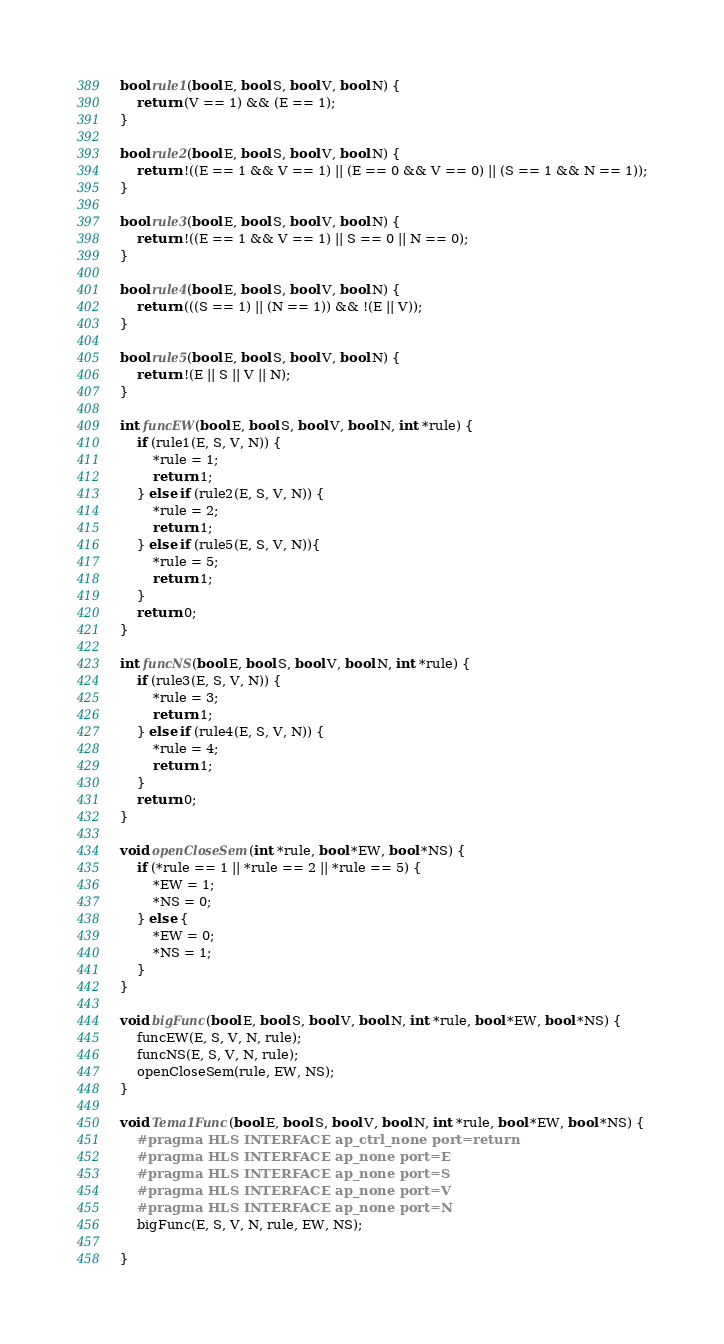Convert code to text. <code><loc_0><loc_0><loc_500><loc_500><_C++_>bool rule1(bool E, bool S, bool V, bool N) {
	return (V == 1) && (E == 1);
}

bool rule2(bool E, bool S, bool V, bool N) {
	return !((E == 1 && V == 1) || (E == 0 && V == 0) || (S == 1 && N == 1));
}

bool rule3(bool E, bool S, bool V, bool N) {
	return !((E == 1 && V == 1) || S == 0 || N == 0);
}

bool rule4(bool E, bool S, bool V, bool N) {
	return (((S == 1) || (N == 1)) && !(E || V));
}

bool rule5(bool E, bool S, bool V, bool N) {
	return !(E || S || V || N);
}

int funcEW(bool E, bool S, bool V, bool N, int *rule) {
	if (rule1(E, S, V, N)) {
		*rule = 1;
		return 1;
	} else if (rule2(E, S, V, N)) {
		*rule = 2;
		return 1;
	} else if (rule5(E, S, V, N)){
		*rule = 5;
		return 1;
	}
	return 0;
}

int funcNS(bool E, bool S, bool V, bool N, int *rule) {
	if (rule3(E, S, V, N)) {
		*rule = 3;
		return 1;
	} else if (rule4(E, S, V, N)) {
		*rule = 4;
		return 1;
	}
	return 0;
}

void openCloseSem(int *rule, bool *EW, bool *NS) {
	if (*rule == 1 || *rule == 2 || *rule == 5) {
		*EW = 1;
		*NS = 0;
	} else {
		*EW = 0;
		*NS = 1;
	}
}

void bigFunc(bool E, bool S, bool V, bool N, int *rule, bool *EW, bool *NS) {
	funcEW(E, S, V, N, rule);
	funcNS(E, S, V, N, rule);
	openCloseSem(rule, EW, NS);
}

void Tema1Func(bool E, bool S, bool V, bool N, int *rule, bool *EW, bool *NS) {
	#pragma HLS INTERFACE ap_ctrl_none port=return
	#pragma HLS INTERFACE ap_none port=E
	#pragma HLS INTERFACE ap_none port=S
	#pragma HLS INTERFACE ap_none port=V
	#pragma HLS INTERFACE ap_none port=N
	bigFunc(E, S, V, N, rule, EW, NS);

}
</code> 